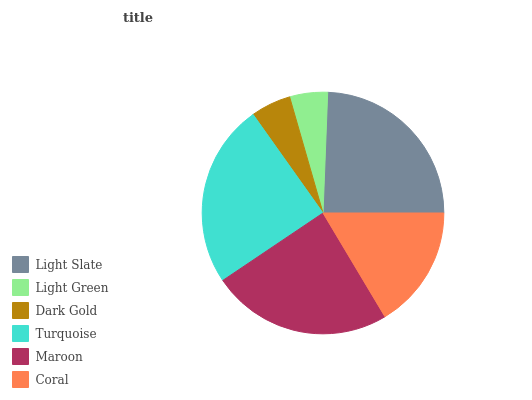Is Light Green the minimum?
Answer yes or no. Yes. Is Turquoise the maximum?
Answer yes or no. Yes. Is Dark Gold the minimum?
Answer yes or no. No. Is Dark Gold the maximum?
Answer yes or no. No. Is Dark Gold greater than Light Green?
Answer yes or no. Yes. Is Light Green less than Dark Gold?
Answer yes or no. Yes. Is Light Green greater than Dark Gold?
Answer yes or no. No. Is Dark Gold less than Light Green?
Answer yes or no. No. Is Maroon the high median?
Answer yes or no. Yes. Is Coral the low median?
Answer yes or no. Yes. Is Turquoise the high median?
Answer yes or no. No. Is Light Slate the low median?
Answer yes or no. No. 